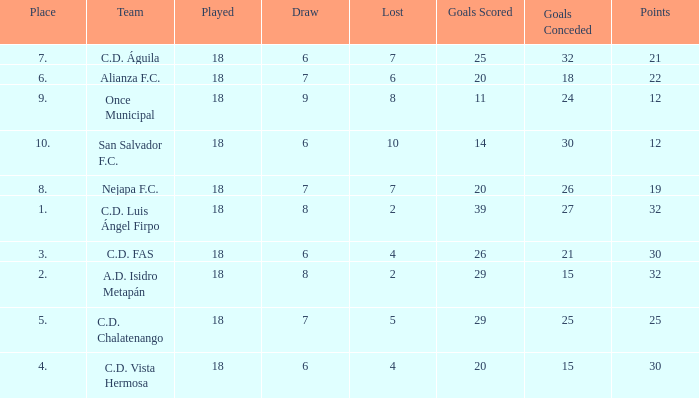What is the sum of draw with a lost smaller than 6, and a place of 5, and a goals scored less than 29? None. 